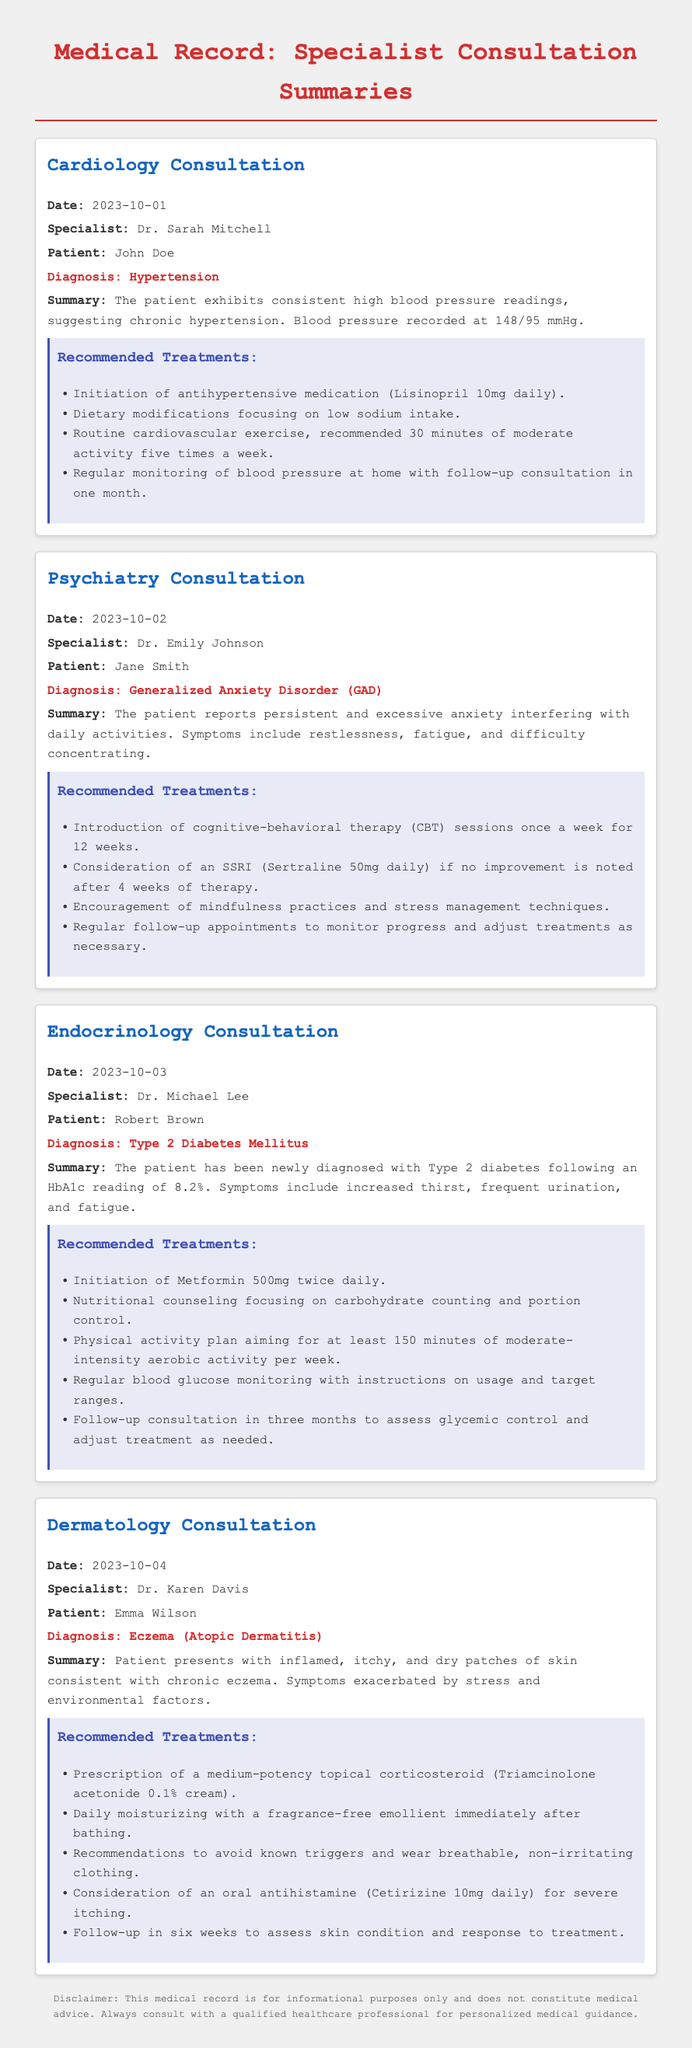What is the date of the Cardiology Consultation? The date for the Cardiology Consultation is mentioned in the document as 2023-10-01.
Answer: 2023-10-01 Who was the specialist for the Psychiatry Consultation? The specialist for the Psychiatry Consultation is outlined in the document as Dr. Emily Johnson.
Answer: Dr. Emily Johnson What diagnosis did Robert Brown receive during the Endocrinology Consultation? The document specifies that Robert Brown was diagnosed with Type 2 Diabetes Mellitus during his consultation.
Answer: Type 2 Diabetes Mellitus What is one of the recommended treatments for Eczema? The document notes the prescription of a medium-potency topical corticosteroid (Triamcinolone acetonide 0.1% cream) as a treatment for Eczema.
Answer: Triamcinolone acetonide 0.1% cream What are the recommended physical activity minutes per week for the patient diagnosed with Type 2 Diabetes? The recommended activity level discussed in the document is at least 150 minutes of moderate-intensity aerobic activity per week for the diabetes patient.
Answer: 150 minutes What condition is suggested to be exacerbated by stress in the Dermatology Consultation? The document highlights that Eczema is exacerbated by stress in the patient's consultation.
Answer: Eczema How often should John Doe monitor his blood pressure at home? The document states that John Doe should regularly monitor his blood pressure at home.
Answer: Regularly What type of therapy is recommended for Jane Smith? The document recommends cognitive-behavioral therapy (CBT) sessions for Jane Smith.
Answer: Cognitive-behavioral therapy (CBT) 